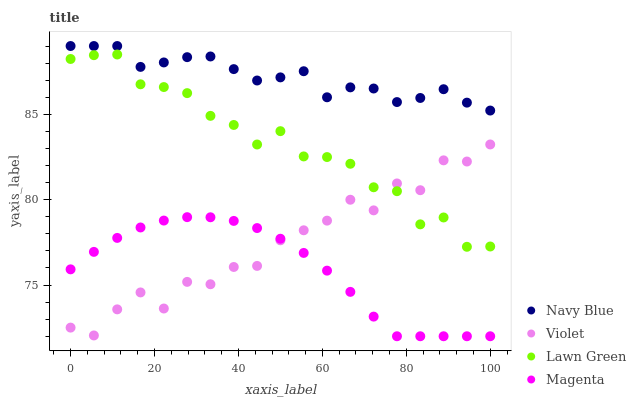Does Magenta have the minimum area under the curve?
Answer yes or no. Yes. Does Navy Blue have the maximum area under the curve?
Answer yes or no. Yes. Does Lawn Green have the minimum area under the curve?
Answer yes or no. No. Does Lawn Green have the maximum area under the curve?
Answer yes or no. No. Is Magenta the smoothest?
Answer yes or no. Yes. Is Violet the roughest?
Answer yes or no. Yes. Is Lawn Green the smoothest?
Answer yes or no. No. Is Lawn Green the roughest?
Answer yes or no. No. Does Magenta have the lowest value?
Answer yes or no. Yes. Does Lawn Green have the lowest value?
Answer yes or no. No. Does Navy Blue have the highest value?
Answer yes or no. Yes. Does Lawn Green have the highest value?
Answer yes or no. No. Is Violet less than Navy Blue?
Answer yes or no. Yes. Is Navy Blue greater than Violet?
Answer yes or no. Yes. Does Violet intersect Lawn Green?
Answer yes or no. Yes. Is Violet less than Lawn Green?
Answer yes or no. No. Is Violet greater than Lawn Green?
Answer yes or no. No. Does Violet intersect Navy Blue?
Answer yes or no. No. 